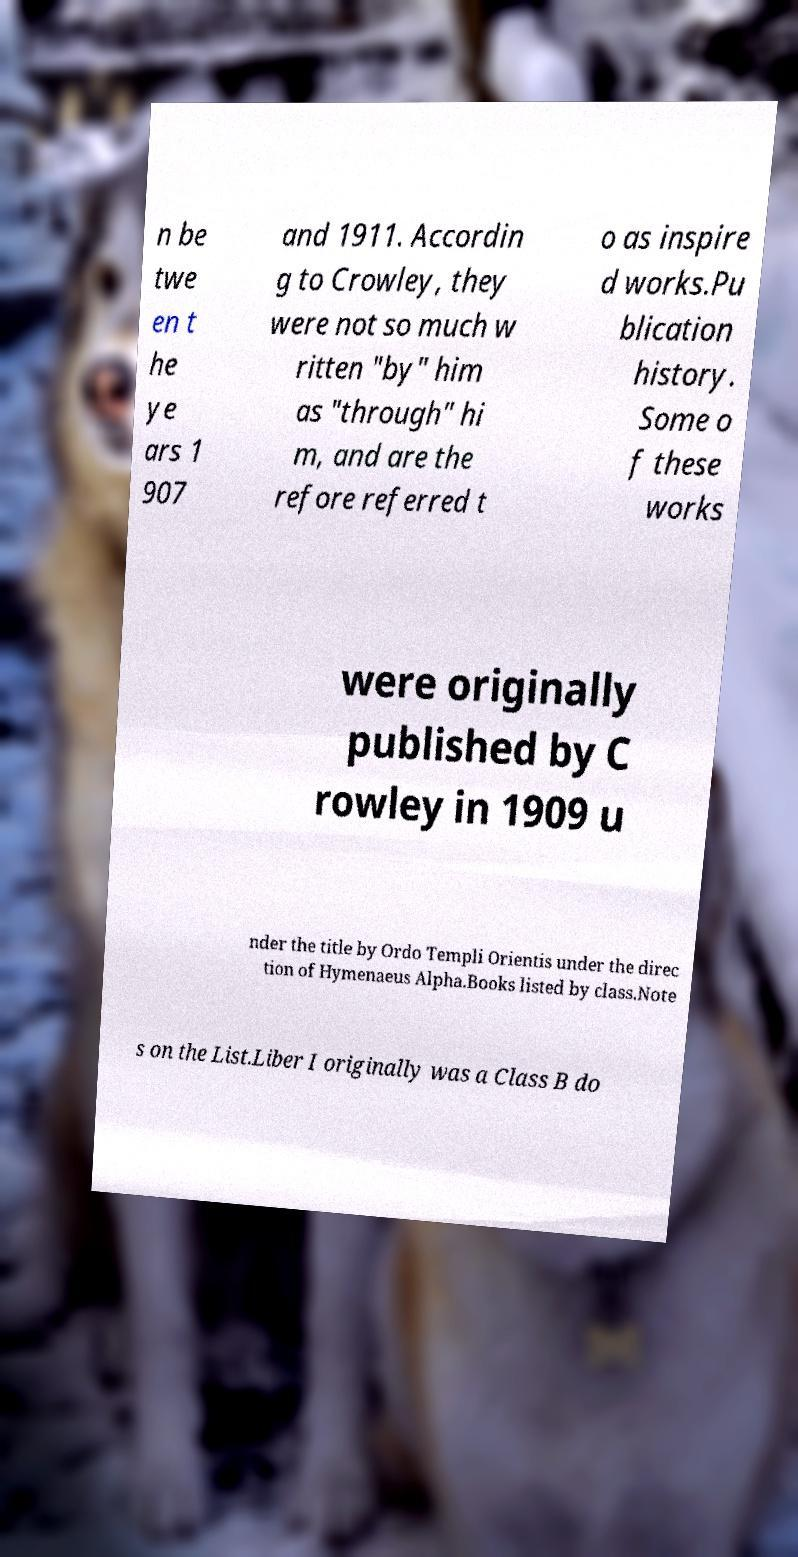There's text embedded in this image that I need extracted. Can you transcribe it verbatim? n be twe en t he ye ars 1 907 and 1911. Accordin g to Crowley, they were not so much w ritten "by" him as "through" hi m, and are the refore referred t o as inspire d works.Pu blication history. Some o f these works were originally published by C rowley in 1909 u nder the title by Ordo Templi Orientis under the direc tion of Hymenaeus Alpha.Books listed by class.Note s on the List.Liber I originally was a Class B do 